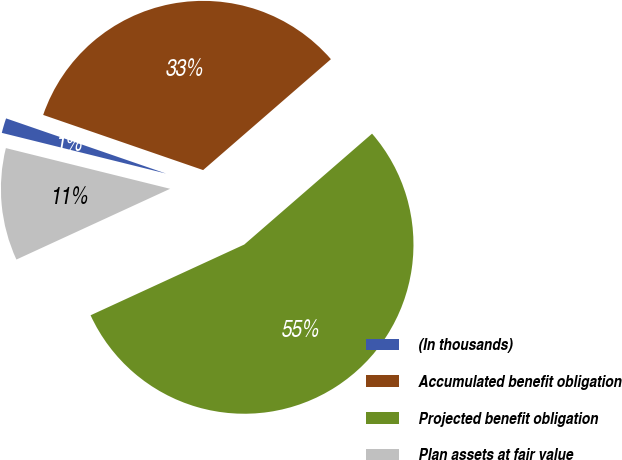Convert chart to OTSL. <chart><loc_0><loc_0><loc_500><loc_500><pie_chart><fcel>(In thousands)<fcel>Accumulated benefit obligation<fcel>Projected benefit obligation<fcel>Plan assets at fair value<nl><fcel>1.42%<fcel>33.34%<fcel>54.51%<fcel>10.73%<nl></chart> 